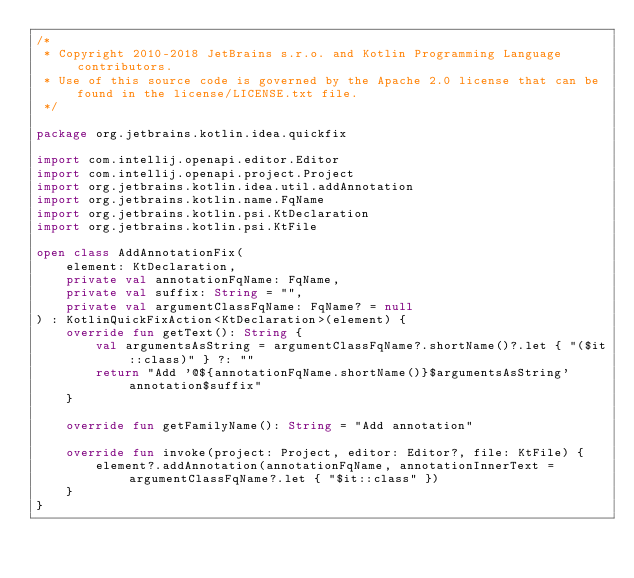Convert code to text. <code><loc_0><loc_0><loc_500><loc_500><_Kotlin_>/*
 * Copyright 2010-2018 JetBrains s.r.o. and Kotlin Programming Language contributors.
 * Use of this source code is governed by the Apache 2.0 license that can be found in the license/LICENSE.txt file.
 */

package org.jetbrains.kotlin.idea.quickfix

import com.intellij.openapi.editor.Editor
import com.intellij.openapi.project.Project
import org.jetbrains.kotlin.idea.util.addAnnotation
import org.jetbrains.kotlin.name.FqName
import org.jetbrains.kotlin.psi.KtDeclaration
import org.jetbrains.kotlin.psi.KtFile

open class AddAnnotationFix(
    element: KtDeclaration,
    private val annotationFqName: FqName,
    private val suffix: String = "",
    private val argumentClassFqName: FqName? = null
) : KotlinQuickFixAction<KtDeclaration>(element) {
    override fun getText(): String {
        val argumentsAsString = argumentClassFqName?.shortName()?.let { "($it::class)" } ?: ""
        return "Add '@${annotationFqName.shortName()}$argumentsAsString' annotation$suffix"
    }

    override fun getFamilyName(): String = "Add annotation"

    override fun invoke(project: Project, editor: Editor?, file: KtFile) {
        element?.addAnnotation(annotationFqName, annotationInnerText = argumentClassFqName?.let { "$it::class" })
    }
}</code> 